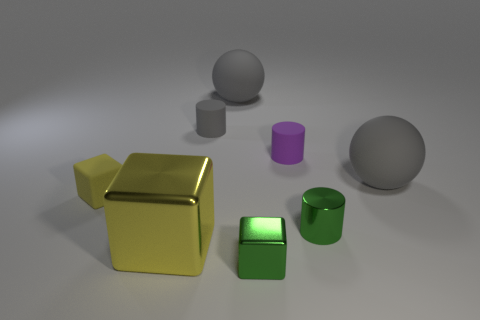Add 1 tiny gray rubber cylinders. How many objects exist? 9 Subtract all spheres. How many objects are left? 6 Subtract all purple blocks. Subtract all yellow objects. How many objects are left? 6 Add 7 gray rubber things. How many gray rubber things are left? 10 Add 3 small yellow cubes. How many small yellow cubes exist? 4 Subtract 0 yellow cylinders. How many objects are left? 8 